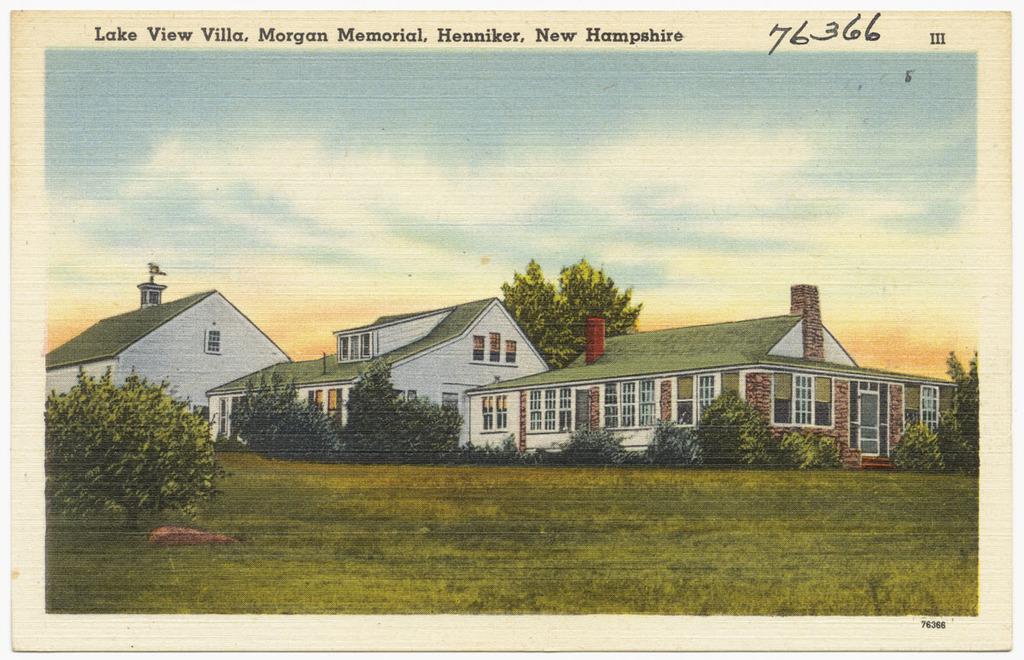Where is the house located?
Ensure brevity in your answer.  New hampshire. 